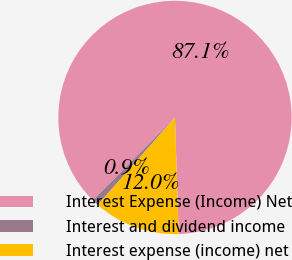Convert chart. <chart><loc_0><loc_0><loc_500><loc_500><pie_chart><fcel>Interest Expense (Income) Net<fcel>Interest and dividend income<fcel>Interest expense (income) net<nl><fcel>87.07%<fcel>0.91%<fcel>12.02%<nl></chart> 